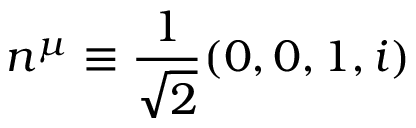<formula> <loc_0><loc_0><loc_500><loc_500>n ^ { \mu } \equiv \frac { 1 } { \sqrt { 2 } } ( 0 , 0 , 1 , i )</formula> 